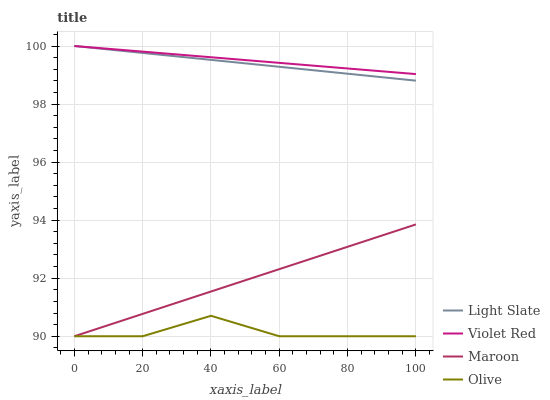Does Olive have the minimum area under the curve?
Answer yes or no. Yes. Does Violet Red have the maximum area under the curve?
Answer yes or no. Yes. Does Violet Red have the minimum area under the curve?
Answer yes or no. No. Does Olive have the maximum area under the curve?
Answer yes or no. No. Is Maroon the smoothest?
Answer yes or no. Yes. Is Olive the roughest?
Answer yes or no. Yes. Is Violet Red the smoothest?
Answer yes or no. No. Is Violet Red the roughest?
Answer yes or no. No. Does Olive have the lowest value?
Answer yes or no. Yes. Does Violet Red have the lowest value?
Answer yes or no. No. Does Violet Red have the highest value?
Answer yes or no. Yes. Does Olive have the highest value?
Answer yes or no. No. Is Maroon less than Violet Red?
Answer yes or no. Yes. Is Violet Red greater than Olive?
Answer yes or no. Yes. Does Violet Red intersect Light Slate?
Answer yes or no. Yes. Is Violet Red less than Light Slate?
Answer yes or no. No. Is Violet Red greater than Light Slate?
Answer yes or no. No. Does Maroon intersect Violet Red?
Answer yes or no. No. 